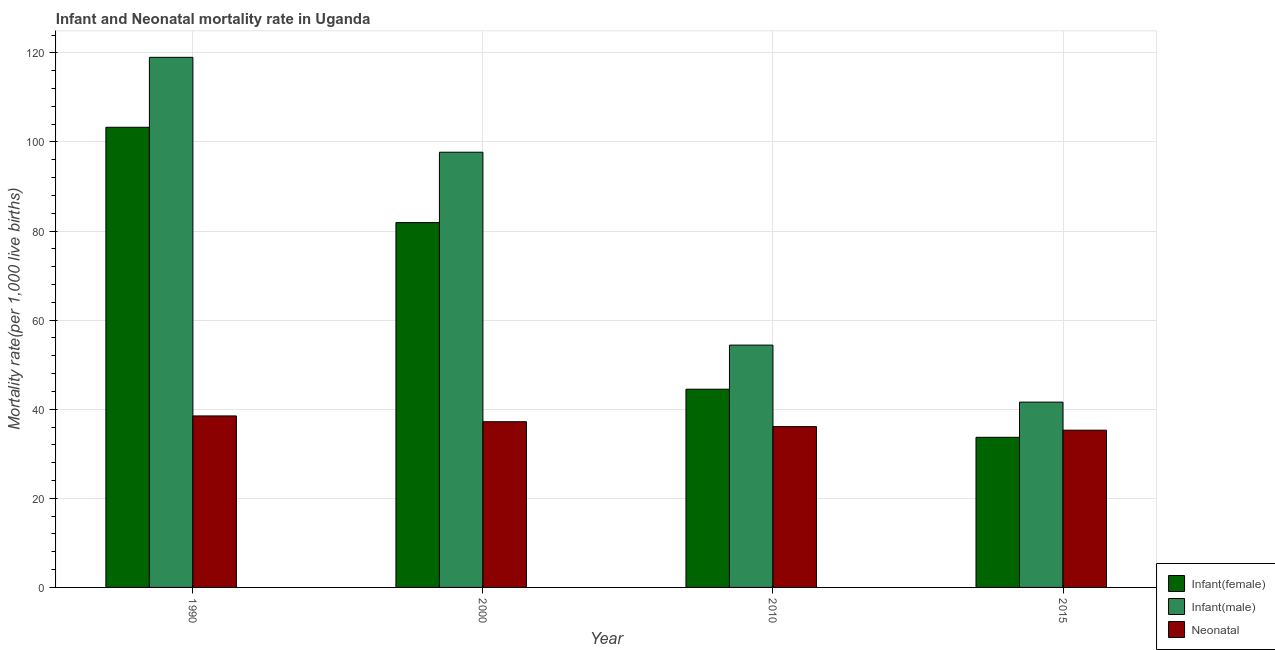Are the number of bars on each tick of the X-axis equal?
Provide a short and direct response. Yes. How many bars are there on the 4th tick from the left?
Ensure brevity in your answer.  3. How many bars are there on the 3rd tick from the right?
Your response must be concise. 3. What is the label of the 1st group of bars from the left?
Provide a short and direct response. 1990. In how many cases, is the number of bars for a given year not equal to the number of legend labels?
Provide a succinct answer. 0. What is the infant mortality rate(male) in 1990?
Keep it short and to the point. 119. Across all years, what is the maximum neonatal mortality rate?
Provide a short and direct response. 38.5. Across all years, what is the minimum neonatal mortality rate?
Keep it short and to the point. 35.3. In which year was the infant mortality rate(male) minimum?
Give a very brief answer. 2015. What is the total infant mortality rate(female) in the graph?
Your answer should be compact. 263.4. What is the difference between the neonatal mortality rate in 2000 and that in 2015?
Make the answer very short. 1.9. What is the difference between the infant mortality rate(female) in 2015 and the neonatal mortality rate in 2000?
Make the answer very short. -48.2. What is the average infant mortality rate(male) per year?
Provide a succinct answer. 78.17. In the year 1990, what is the difference between the infant mortality rate(female) and infant mortality rate(male)?
Provide a succinct answer. 0. What is the ratio of the infant mortality rate(male) in 1990 to that in 2010?
Your answer should be very brief. 2.19. Is the infant mortality rate(male) in 2010 less than that in 2015?
Your answer should be very brief. No. What is the difference between the highest and the second highest infant mortality rate(male)?
Give a very brief answer. 21.3. What is the difference between the highest and the lowest neonatal mortality rate?
Your response must be concise. 3.2. What does the 1st bar from the left in 2015 represents?
Provide a short and direct response. Infant(female). What does the 3rd bar from the right in 2000 represents?
Keep it short and to the point. Infant(female). How many years are there in the graph?
Your response must be concise. 4. What is the difference between two consecutive major ticks on the Y-axis?
Keep it short and to the point. 20. Are the values on the major ticks of Y-axis written in scientific E-notation?
Keep it short and to the point. No. Does the graph contain any zero values?
Offer a terse response. No. Does the graph contain grids?
Give a very brief answer. Yes. How many legend labels are there?
Give a very brief answer. 3. What is the title of the graph?
Your answer should be very brief. Infant and Neonatal mortality rate in Uganda. What is the label or title of the Y-axis?
Provide a short and direct response. Mortality rate(per 1,0 live births). What is the Mortality rate(per 1,000 live births) in Infant(female) in 1990?
Your answer should be compact. 103.3. What is the Mortality rate(per 1,000 live births) in Infant(male) in 1990?
Keep it short and to the point. 119. What is the Mortality rate(per 1,000 live births) of Neonatal  in 1990?
Your answer should be compact. 38.5. What is the Mortality rate(per 1,000 live births) of Infant(female) in 2000?
Your response must be concise. 81.9. What is the Mortality rate(per 1,000 live births) in Infant(male) in 2000?
Ensure brevity in your answer.  97.7. What is the Mortality rate(per 1,000 live births) in Neonatal  in 2000?
Offer a terse response. 37.2. What is the Mortality rate(per 1,000 live births) in Infant(female) in 2010?
Your answer should be very brief. 44.5. What is the Mortality rate(per 1,000 live births) in Infant(male) in 2010?
Make the answer very short. 54.4. What is the Mortality rate(per 1,000 live births) in Neonatal  in 2010?
Offer a terse response. 36.1. What is the Mortality rate(per 1,000 live births) in Infant(female) in 2015?
Keep it short and to the point. 33.7. What is the Mortality rate(per 1,000 live births) of Infant(male) in 2015?
Ensure brevity in your answer.  41.6. What is the Mortality rate(per 1,000 live births) in Neonatal  in 2015?
Give a very brief answer. 35.3. Across all years, what is the maximum Mortality rate(per 1,000 live births) of Infant(female)?
Provide a short and direct response. 103.3. Across all years, what is the maximum Mortality rate(per 1,000 live births) in Infant(male)?
Your answer should be compact. 119. Across all years, what is the maximum Mortality rate(per 1,000 live births) of Neonatal ?
Offer a terse response. 38.5. Across all years, what is the minimum Mortality rate(per 1,000 live births) in Infant(female)?
Provide a short and direct response. 33.7. Across all years, what is the minimum Mortality rate(per 1,000 live births) of Infant(male)?
Offer a terse response. 41.6. Across all years, what is the minimum Mortality rate(per 1,000 live births) in Neonatal ?
Your answer should be very brief. 35.3. What is the total Mortality rate(per 1,000 live births) of Infant(female) in the graph?
Give a very brief answer. 263.4. What is the total Mortality rate(per 1,000 live births) of Infant(male) in the graph?
Keep it short and to the point. 312.7. What is the total Mortality rate(per 1,000 live births) of Neonatal  in the graph?
Your response must be concise. 147.1. What is the difference between the Mortality rate(per 1,000 live births) in Infant(female) in 1990 and that in 2000?
Offer a very short reply. 21.4. What is the difference between the Mortality rate(per 1,000 live births) in Infant(male) in 1990 and that in 2000?
Make the answer very short. 21.3. What is the difference between the Mortality rate(per 1,000 live births) in Neonatal  in 1990 and that in 2000?
Your answer should be very brief. 1.3. What is the difference between the Mortality rate(per 1,000 live births) in Infant(female) in 1990 and that in 2010?
Your answer should be compact. 58.8. What is the difference between the Mortality rate(per 1,000 live births) of Infant(male) in 1990 and that in 2010?
Keep it short and to the point. 64.6. What is the difference between the Mortality rate(per 1,000 live births) in Infant(female) in 1990 and that in 2015?
Your answer should be very brief. 69.6. What is the difference between the Mortality rate(per 1,000 live births) of Infant(male) in 1990 and that in 2015?
Keep it short and to the point. 77.4. What is the difference between the Mortality rate(per 1,000 live births) of Infant(female) in 2000 and that in 2010?
Your answer should be compact. 37.4. What is the difference between the Mortality rate(per 1,000 live births) in Infant(male) in 2000 and that in 2010?
Make the answer very short. 43.3. What is the difference between the Mortality rate(per 1,000 live births) of Infant(female) in 2000 and that in 2015?
Give a very brief answer. 48.2. What is the difference between the Mortality rate(per 1,000 live births) in Infant(male) in 2000 and that in 2015?
Offer a terse response. 56.1. What is the difference between the Mortality rate(per 1,000 live births) of Neonatal  in 2010 and that in 2015?
Give a very brief answer. 0.8. What is the difference between the Mortality rate(per 1,000 live births) in Infant(female) in 1990 and the Mortality rate(per 1,000 live births) in Infant(male) in 2000?
Make the answer very short. 5.6. What is the difference between the Mortality rate(per 1,000 live births) in Infant(female) in 1990 and the Mortality rate(per 1,000 live births) in Neonatal  in 2000?
Provide a short and direct response. 66.1. What is the difference between the Mortality rate(per 1,000 live births) of Infant(male) in 1990 and the Mortality rate(per 1,000 live births) of Neonatal  in 2000?
Keep it short and to the point. 81.8. What is the difference between the Mortality rate(per 1,000 live births) in Infant(female) in 1990 and the Mortality rate(per 1,000 live births) in Infant(male) in 2010?
Ensure brevity in your answer.  48.9. What is the difference between the Mortality rate(per 1,000 live births) of Infant(female) in 1990 and the Mortality rate(per 1,000 live births) of Neonatal  in 2010?
Offer a very short reply. 67.2. What is the difference between the Mortality rate(per 1,000 live births) in Infant(male) in 1990 and the Mortality rate(per 1,000 live births) in Neonatal  in 2010?
Offer a very short reply. 82.9. What is the difference between the Mortality rate(per 1,000 live births) of Infant(female) in 1990 and the Mortality rate(per 1,000 live births) of Infant(male) in 2015?
Provide a succinct answer. 61.7. What is the difference between the Mortality rate(per 1,000 live births) in Infant(female) in 1990 and the Mortality rate(per 1,000 live births) in Neonatal  in 2015?
Your response must be concise. 68. What is the difference between the Mortality rate(per 1,000 live births) in Infant(male) in 1990 and the Mortality rate(per 1,000 live births) in Neonatal  in 2015?
Keep it short and to the point. 83.7. What is the difference between the Mortality rate(per 1,000 live births) of Infant(female) in 2000 and the Mortality rate(per 1,000 live births) of Neonatal  in 2010?
Provide a succinct answer. 45.8. What is the difference between the Mortality rate(per 1,000 live births) in Infant(male) in 2000 and the Mortality rate(per 1,000 live births) in Neonatal  in 2010?
Provide a succinct answer. 61.6. What is the difference between the Mortality rate(per 1,000 live births) in Infant(female) in 2000 and the Mortality rate(per 1,000 live births) in Infant(male) in 2015?
Provide a succinct answer. 40.3. What is the difference between the Mortality rate(per 1,000 live births) in Infant(female) in 2000 and the Mortality rate(per 1,000 live births) in Neonatal  in 2015?
Your answer should be very brief. 46.6. What is the difference between the Mortality rate(per 1,000 live births) in Infant(male) in 2000 and the Mortality rate(per 1,000 live births) in Neonatal  in 2015?
Provide a succinct answer. 62.4. What is the difference between the Mortality rate(per 1,000 live births) in Infant(female) in 2010 and the Mortality rate(per 1,000 live births) in Infant(male) in 2015?
Offer a very short reply. 2.9. What is the difference between the Mortality rate(per 1,000 live births) of Infant(female) in 2010 and the Mortality rate(per 1,000 live births) of Neonatal  in 2015?
Provide a short and direct response. 9.2. What is the average Mortality rate(per 1,000 live births) in Infant(female) per year?
Offer a very short reply. 65.85. What is the average Mortality rate(per 1,000 live births) of Infant(male) per year?
Offer a very short reply. 78.17. What is the average Mortality rate(per 1,000 live births) in Neonatal  per year?
Offer a very short reply. 36.77. In the year 1990, what is the difference between the Mortality rate(per 1,000 live births) in Infant(female) and Mortality rate(per 1,000 live births) in Infant(male)?
Provide a succinct answer. -15.7. In the year 1990, what is the difference between the Mortality rate(per 1,000 live births) in Infant(female) and Mortality rate(per 1,000 live births) in Neonatal ?
Your answer should be very brief. 64.8. In the year 1990, what is the difference between the Mortality rate(per 1,000 live births) of Infant(male) and Mortality rate(per 1,000 live births) of Neonatal ?
Your answer should be very brief. 80.5. In the year 2000, what is the difference between the Mortality rate(per 1,000 live births) in Infant(female) and Mortality rate(per 1,000 live births) in Infant(male)?
Your answer should be very brief. -15.8. In the year 2000, what is the difference between the Mortality rate(per 1,000 live births) of Infant(female) and Mortality rate(per 1,000 live births) of Neonatal ?
Provide a succinct answer. 44.7. In the year 2000, what is the difference between the Mortality rate(per 1,000 live births) in Infant(male) and Mortality rate(per 1,000 live births) in Neonatal ?
Give a very brief answer. 60.5. In the year 2010, what is the difference between the Mortality rate(per 1,000 live births) of Infant(male) and Mortality rate(per 1,000 live births) of Neonatal ?
Keep it short and to the point. 18.3. In the year 2015, what is the difference between the Mortality rate(per 1,000 live births) of Infant(female) and Mortality rate(per 1,000 live births) of Neonatal ?
Provide a succinct answer. -1.6. In the year 2015, what is the difference between the Mortality rate(per 1,000 live births) in Infant(male) and Mortality rate(per 1,000 live births) in Neonatal ?
Your answer should be very brief. 6.3. What is the ratio of the Mortality rate(per 1,000 live births) in Infant(female) in 1990 to that in 2000?
Offer a terse response. 1.26. What is the ratio of the Mortality rate(per 1,000 live births) of Infant(male) in 1990 to that in 2000?
Offer a very short reply. 1.22. What is the ratio of the Mortality rate(per 1,000 live births) in Neonatal  in 1990 to that in 2000?
Your answer should be compact. 1.03. What is the ratio of the Mortality rate(per 1,000 live births) of Infant(female) in 1990 to that in 2010?
Ensure brevity in your answer.  2.32. What is the ratio of the Mortality rate(per 1,000 live births) in Infant(male) in 1990 to that in 2010?
Your answer should be compact. 2.19. What is the ratio of the Mortality rate(per 1,000 live births) of Neonatal  in 1990 to that in 2010?
Offer a terse response. 1.07. What is the ratio of the Mortality rate(per 1,000 live births) in Infant(female) in 1990 to that in 2015?
Your answer should be compact. 3.07. What is the ratio of the Mortality rate(per 1,000 live births) of Infant(male) in 1990 to that in 2015?
Make the answer very short. 2.86. What is the ratio of the Mortality rate(per 1,000 live births) of Neonatal  in 1990 to that in 2015?
Give a very brief answer. 1.09. What is the ratio of the Mortality rate(per 1,000 live births) of Infant(female) in 2000 to that in 2010?
Your answer should be very brief. 1.84. What is the ratio of the Mortality rate(per 1,000 live births) of Infant(male) in 2000 to that in 2010?
Provide a short and direct response. 1.8. What is the ratio of the Mortality rate(per 1,000 live births) of Neonatal  in 2000 to that in 2010?
Your answer should be compact. 1.03. What is the ratio of the Mortality rate(per 1,000 live births) in Infant(female) in 2000 to that in 2015?
Offer a terse response. 2.43. What is the ratio of the Mortality rate(per 1,000 live births) in Infant(male) in 2000 to that in 2015?
Your answer should be compact. 2.35. What is the ratio of the Mortality rate(per 1,000 live births) in Neonatal  in 2000 to that in 2015?
Give a very brief answer. 1.05. What is the ratio of the Mortality rate(per 1,000 live births) in Infant(female) in 2010 to that in 2015?
Keep it short and to the point. 1.32. What is the ratio of the Mortality rate(per 1,000 live births) in Infant(male) in 2010 to that in 2015?
Offer a very short reply. 1.31. What is the ratio of the Mortality rate(per 1,000 live births) in Neonatal  in 2010 to that in 2015?
Make the answer very short. 1.02. What is the difference between the highest and the second highest Mortality rate(per 1,000 live births) in Infant(female)?
Provide a succinct answer. 21.4. What is the difference between the highest and the second highest Mortality rate(per 1,000 live births) of Infant(male)?
Your answer should be compact. 21.3. What is the difference between the highest and the lowest Mortality rate(per 1,000 live births) of Infant(female)?
Your answer should be very brief. 69.6. What is the difference between the highest and the lowest Mortality rate(per 1,000 live births) in Infant(male)?
Give a very brief answer. 77.4. 